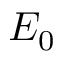<formula> <loc_0><loc_0><loc_500><loc_500>E _ { 0 }</formula> 